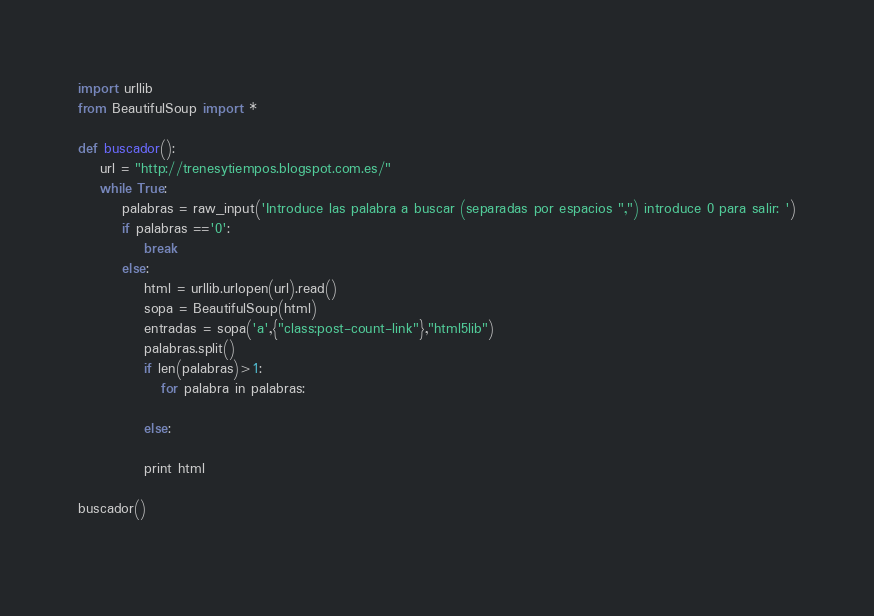Convert code to text. <code><loc_0><loc_0><loc_500><loc_500><_Python_>import urllib
from BeautifulSoup import *

def buscador():
    url = "http://trenesytiempos.blogspot.com.es/"
    while True:
        palabras = raw_input('Introduce las palabra a buscar (separadas por espacios ",") introduce 0 para salir: ')
        if palabras =='0':
            break
        else:
            html = urllib.urlopen(url).read()
            sopa = BeautifulSoup(html)
            entradas = sopa('a',{"class:post-count-link"},"html5lib")
            palabras.split()
            if len(palabras)>1:
               for palabra in palabras:
                   
            else:
                
            print html
            
buscador()
                    
</code> 